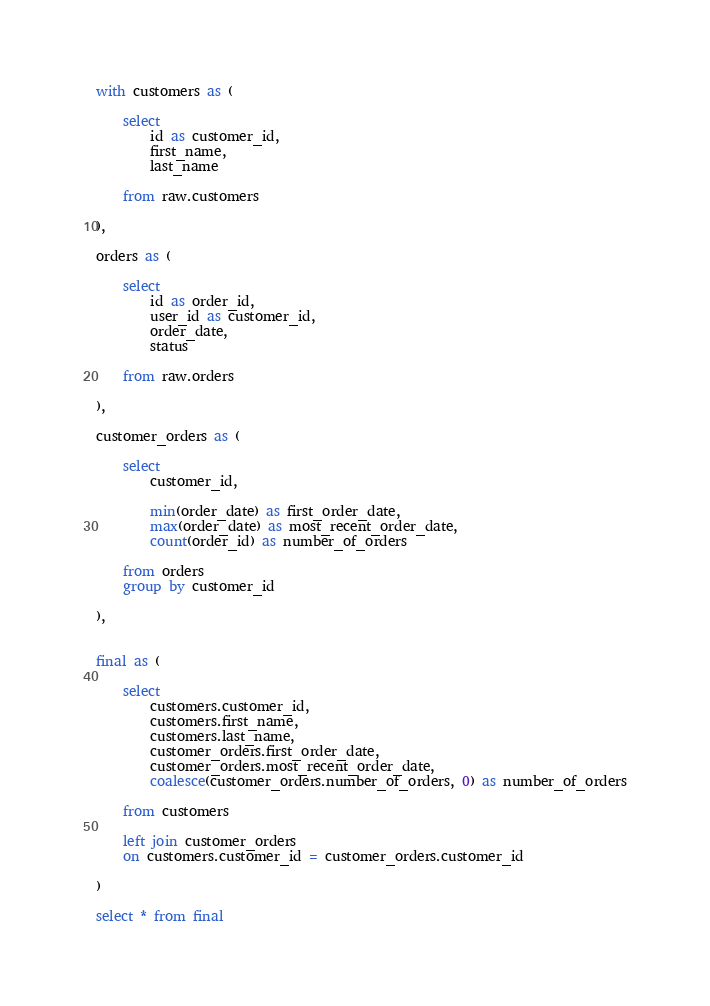Convert code to text. <code><loc_0><loc_0><loc_500><loc_500><_SQL_>with customers as (

    select
        id as customer_id,
        first_name,
        last_name

    from raw.customers

),

orders as (

    select
        id as order_id,
        user_id as customer_id,
        order_date,
        status

    from raw.orders

),

customer_orders as (

    select
        customer_id,

        min(order_date) as first_order_date,
        max(order_date) as most_recent_order_date,
        count(order_id) as number_of_orders

    from orders
    group by customer_id

),


final as (

    select
        customers.customer_id,
        customers.first_name,
        customers.last_name,
        customer_orders.first_order_date,
        customer_orders.most_recent_order_date,
        coalesce(customer_orders.number_of_orders, 0) as number_of_orders

    from customers

    left join customer_orders
    on customers.customer_id = customer_orders.customer_id

)

select * from final</code> 